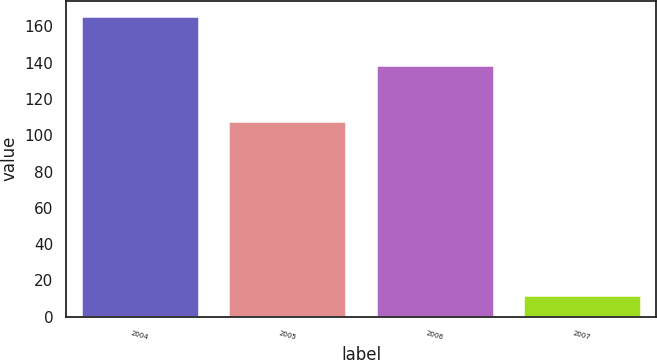Convert chart to OTSL. <chart><loc_0><loc_0><loc_500><loc_500><bar_chart><fcel>2004<fcel>2005<fcel>2006<fcel>2007<nl><fcel>166<fcel>108<fcel>139<fcel>12<nl></chart> 